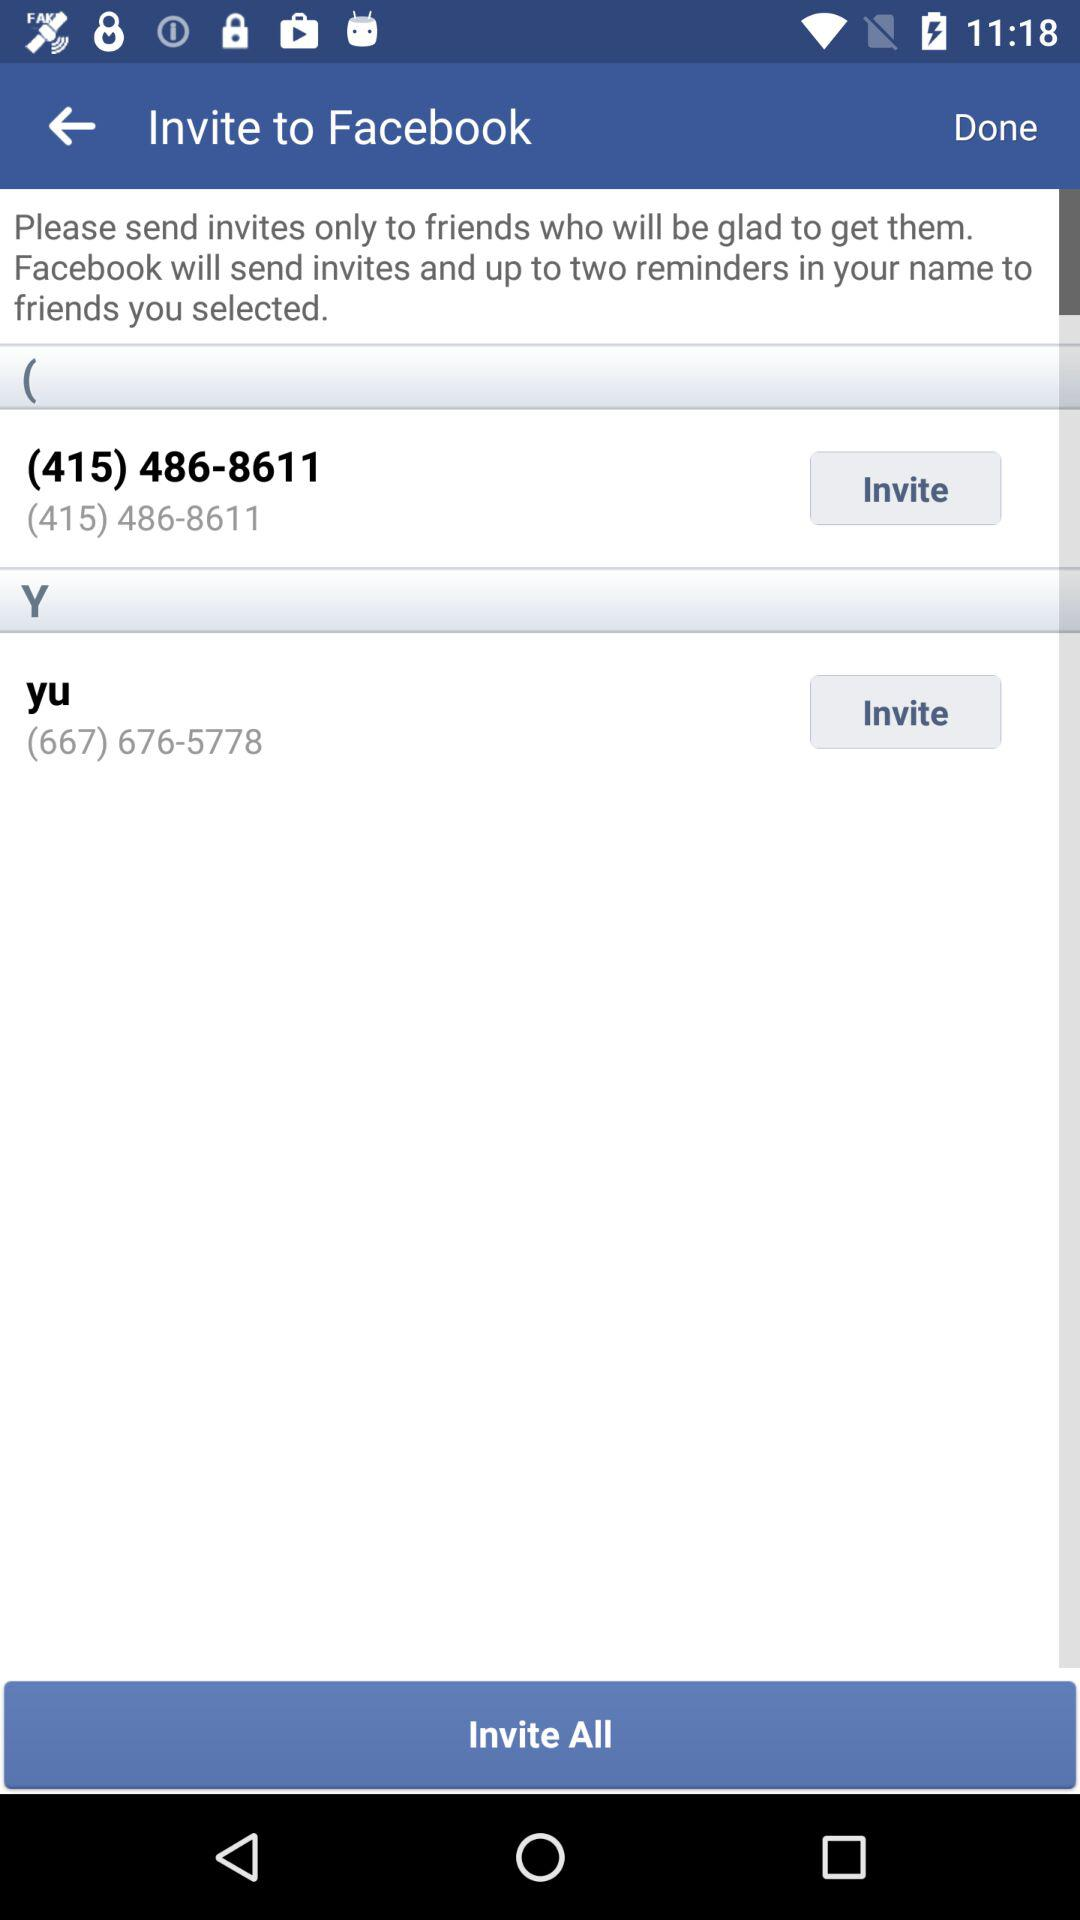What is the phone number for yu? The phone number is (667) 676-5778. 